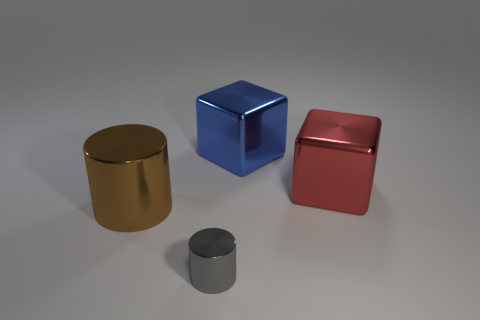Add 4 tiny cylinders. How many objects exist? 8 Subtract all gray cylinders. How many cylinders are left? 1 Subtract 0 green cylinders. How many objects are left? 4 Subtract 1 cylinders. How many cylinders are left? 1 Subtract all brown cylinders. Subtract all purple balls. How many cylinders are left? 1 Subtract all yellow cylinders. How many red blocks are left? 1 Subtract all cubes. Subtract all cylinders. How many objects are left? 0 Add 2 small shiny cylinders. How many small shiny cylinders are left? 3 Add 3 metal cylinders. How many metal cylinders exist? 5 